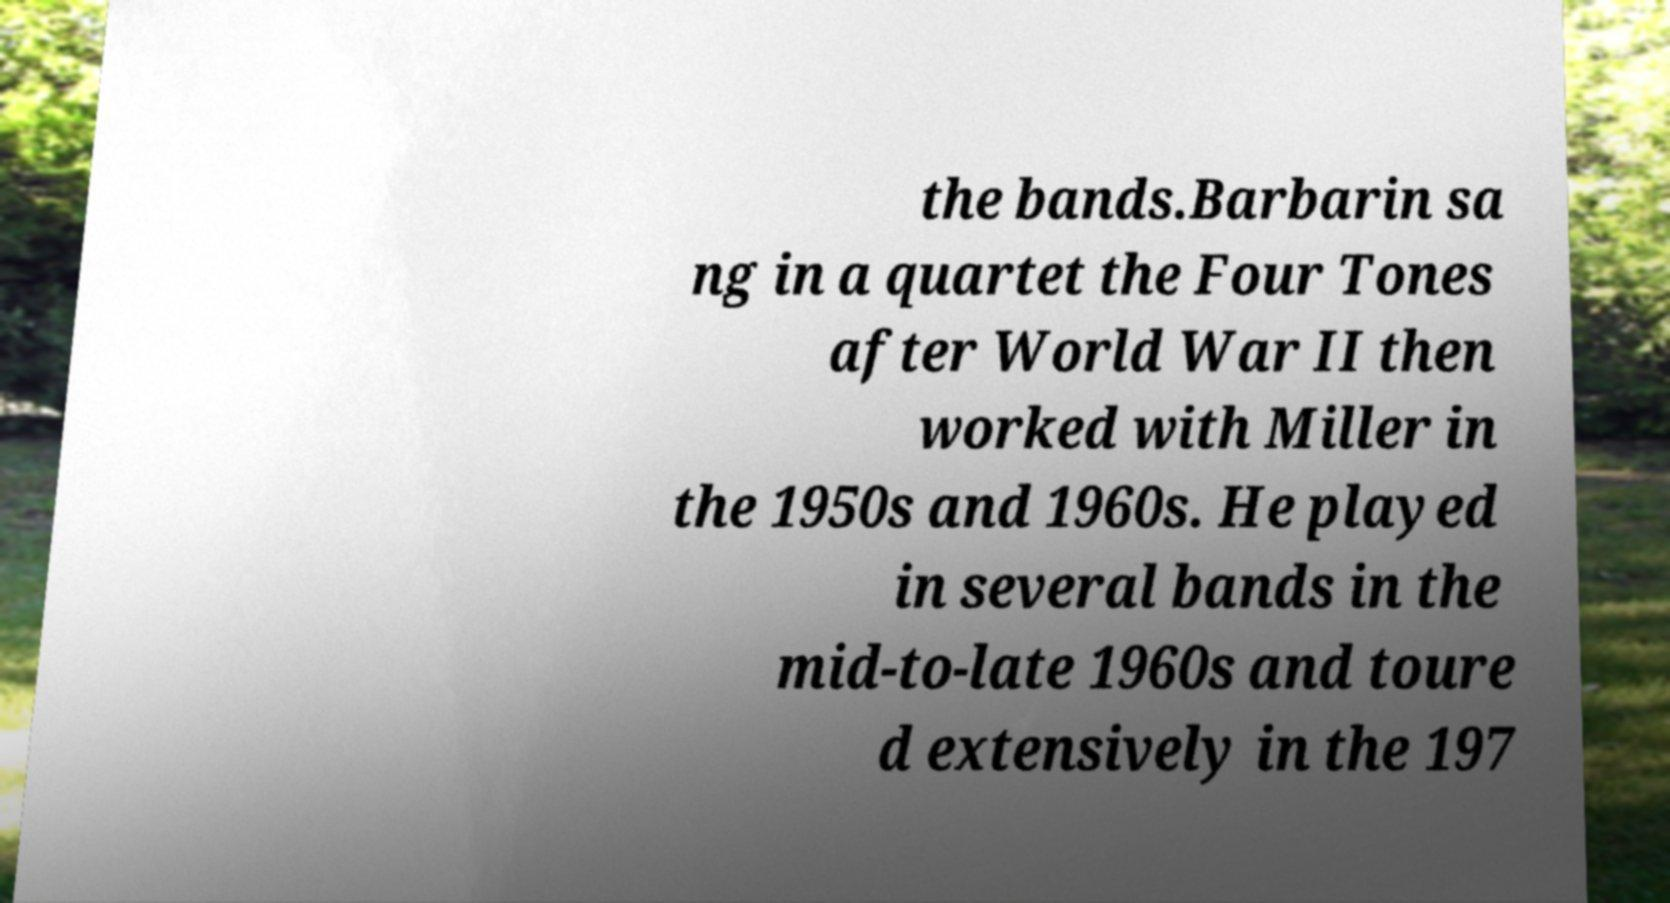What messages or text are displayed in this image? I need them in a readable, typed format. the bands.Barbarin sa ng in a quartet the Four Tones after World War II then worked with Miller in the 1950s and 1960s. He played in several bands in the mid-to-late 1960s and toure d extensively in the 197 